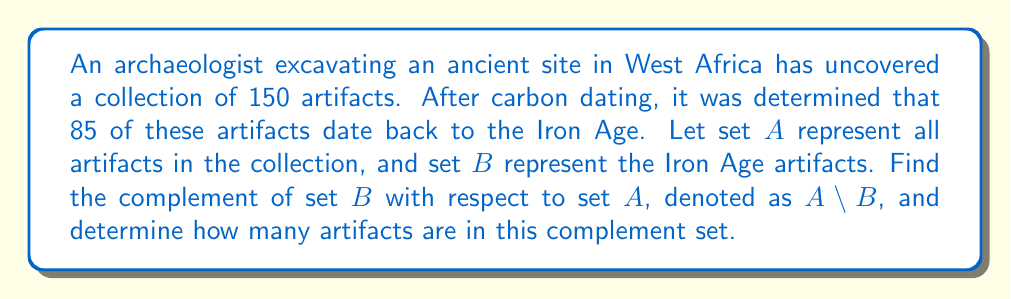Can you solve this math problem? To solve this problem, we need to understand the concept of set complement and then apply it to the given information.

1) The complement of set $B$ with respect to set $A$, denoted as $A \setminus B$, is the set of all elements in $A$ that are not in $B$.

2) We are given:
   - Total number of artifacts (set $A$): 150
   - Number of Iron Age artifacts (set $B$): 85

3) To find the number of artifacts in $A \setminus B$, we need to subtract the number of elements in $B$ from the total number of elements in $A$:

   $$|A \setminus B| = |A| - |B|$$

   Where $|X|$ denotes the cardinality (number of elements) of set $X$.

4) Substituting the given values:

   $$|A \setminus B| = 150 - 85 = 65$$

Therefore, there are 65 artifacts in the complement set $A \setminus B$. These represent the artifacts that are not from the Iron Age.
Answer: The complement of set $B$ with respect to set $A$ ($A \setminus B$) contains 65 artifacts. 